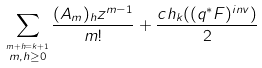<formula> <loc_0><loc_0><loc_500><loc_500>\sum _ { \overset { m + h = k + 1 } { m , h \geq 0 } } \frac { ( A _ { m } ) _ { h } z ^ { m - 1 } } { m ! } + \frac { c h _ { k } ( ( q ^ { * } F ) ^ { i n v } ) } { 2 }</formula> 